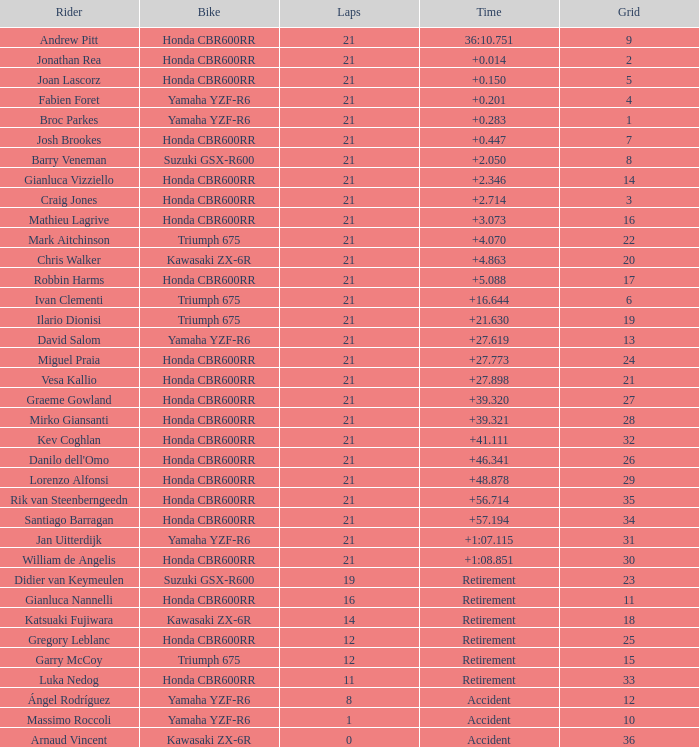Who achieved the best grid placement with a time of +0.283? 1.0. 